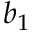Convert formula to latex. <formula><loc_0><loc_0><loc_500><loc_500>b _ { 1 }</formula> 